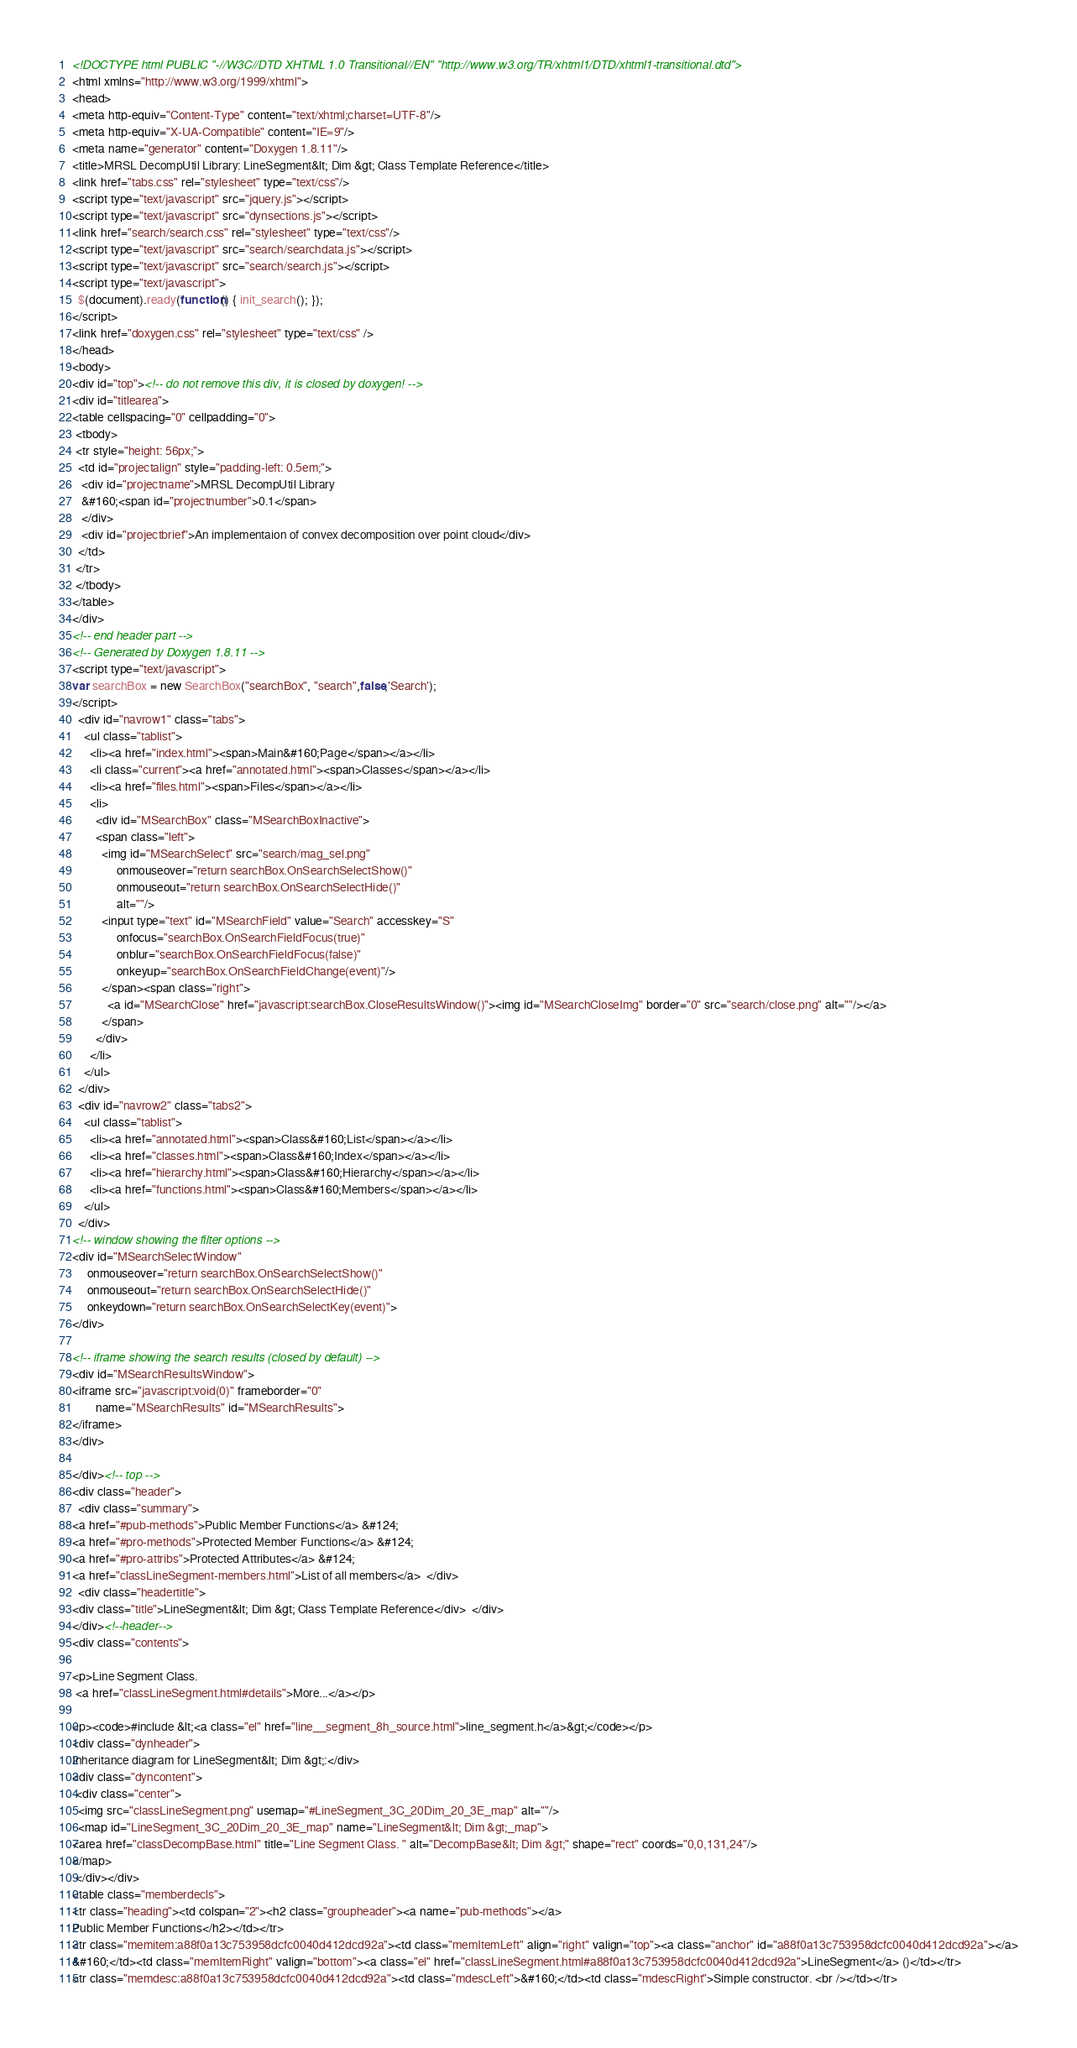<code> <loc_0><loc_0><loc_500><loc_500><_HTML_><!DOCTYPE html PUBLIC "-//W3C//DTD XHTML 1.0 Transitional//EN" "http://www.w3.org/TR/xhtml1/DTD/xhtml1-transitional.dtd">
<html xmlns="http://www.w3.org/1999/xhtml">
<head>
<meta http-equiv="Content-Type" content="text/xhtml;charset=UTF-8"/>
<meta http-equiv="X-UA-Compatible" content="IE=9"/>
<meta name="generator" content="Doxygen 1.8.11"/>
<title>MRSL DecompUtil Library: LineSegment&lt; Dim &gt; Class Template Reference</title>
<link href="tabs.css" rel="stylesheet" type="text/css"/>
<script type="text/javascript" src="jquery.js"></script>
<script type="text/javascript" src="dynsections.js"></script>
<link href="search/search.css" rel="stylesheet" type="text/css"/>
<script type="text/javascript" src="search/searchdata.js"></script>
<script type="text/javascript" src="search/search.js"></script>
<script type="text/javascript">
  $(document).ready(function() { init_search(); });
</script>
<link href="doxygen.css" rel="stylesheet" type="text/css" />
</head>
<body>
<div id="top"><!-- do not remove this div, it is closed by doxygen! -->
<div id="titlearea">
<table cellspacing="0" cellpadding="0">
 <tbody>
 <tr style="height: 56px;">
  <td id="projectalign" style="padding-left: 0.5em;">
   <div id="projectname">MRSL DecompUtil Library
   &#160;<span id="projectnumber">0.1</span>
   </div>
   <div id="projectbrief">An implementaion of convex decomposition over point cloud</div>
  </td>
 </tr>
 </tbody>
</table>
</div>
<!-- end header part -->
<!-- Generated by Doxygen 1.8.11 -->
<script type="text/javascript">
var searchBox = new SearchBox("searchBox", "search",false,'Search');
</script>
  <div id="navrow1" class="tabs">
    <ul class="tablist">
      <li><a href="index.html"><span>Main&#160;Page</span></a></li>
      <li class="current"><a href="annotated.html"><span>Classes</span></a></li>
      <li><a href="files.html"><span>Files</span></a></li>
      <li>
        <div id="MSearchBox" class="MSearchBoxInactive">
        <span class="left">
          <img id="MSearchSelect" src="search/mag_sel.png"
               onmouseover="return searchBox.OnSearchSelectShow()"
               onmouseout="return searchBox.OnSearchSelectHide()"
               alt=""/>
          <input type="text" id="MSearchField" value="Search" accesskey="S"
               onfocus="searchBox.OnSearchFieldFocus(true)" 
               onblur="searchBox.OnSearchFieldFocus(false)" 
               onkeyup="searchBox.OnSearchFieldChange(event)"/>
          </span><span class="right">
            <a id="MSearchClose" href="javascript:searchBox.CloseResultsWindow()"><img id="MSearchCloseImg" border="0" src="search/close.png" alt=""/></a>
          </span>
        </div>
      </li>
    </ul>
  </div>
  <div id="navrow2" class="tabs2">
    <ul class="tablist">
      <li><a href="annotated.html"><span>Class&#160;List</span></a></li>
      <li><a href="classes.html"><span>Class&#160;Index</span></a></li>
      <li><a href="hierarchy.html"><span>Class&#160;Hierarchy</span></a></li>
      <li><a href="functions.html"><span>Class&#160;Members</span></a></li>
    </ul>
  </div>
<!-- window showing the filter options -->
<div id="MSearchSelectWindow"
     onmouseover="return searchBox.OnSearchSelectShow()"
     onmouseout="return searchBox.OnSearchSelectHide()"
     onkeydown="return searchBox.OnSearchSelectKey(event)">
</div>

<!-- iframe showing the search results (closed by default) -->
<div id="MSearchResultsWindow">
<iframe src="javascript:void(0)" frameborder="0" 
        name="MSearchResults" id="MSearchResults">
</iframe>
</div>

</div><!-- top -->
<div class="header">
  <div class="summary">
<a href="#pub-methods">Public Member Functions</a> &#124;
<a href="#pro-methods">Protected Member Functions</a> &#124;
<a href="#pro-attribs">Protected Attributes</a> &#124;
<a href="classLineSegment-members.html">List of all members</a>  </div>
  <div class="headertitle">
<div class="title">LineSegment&lt; Dim &gt; Class Template Reference</div>  </div>
</div><!--header-->
<div class="contents">

<p>Line Segment Class.  
 <a href="classLineSegment.html#details">More...</a></p>

<p><code>#include &lt;<a class="el" href="line__segment_8h_source.html">line_segment.h</a>&gt;</code></p>
<div class="dynheader">
Inheritance diagram for LineSegment&lt; Dim &gt;:</div>
<div class="dyncontent">
 <div class="center">
  <img src="classLineSegment.png" usemap="#LineSegment_3C_20Dim_20_3E_map" alt=""/>
  <map id="LineSegment_3C_20Dim_20_3E_map" name="LineSegment&lt; Dim &gt;_map">
<area href="classDecompBase.html" title="Line Segment Class. " alt="DecompBase&lt; Dim &gt;" shape="rect" coords="0,0,131,24"/>
</map>
 </div></div>
<table class="memberdecls">
<tr class="heading"><td colspan="2"><h2 class="groupheader"><a name="pub-methods"></a>
Public Member Functions</h2></td></tr>
<tr class="memitem:a88f0a13c753958dcfc0040d412dcd92a"><td class="memItemLeft" align="right" valign="top"><a class="anchor" id="a88f0a13c753958dcfc0040d412dcd92a"></a>
&#160;</td><td class="memItemRight" valign="bottom"><a class="el" href="classLineSegment.html#a88f0a13c753958dcfc0040d412dcd92a">LineSegment</a> ()</td></tr>
<tr class="memdesc:a88f0a13c753958dcfc0040d412dcd92a"><td class="mdescLeft">&#160;</td><td class="mdescRight">Simple constructor. <br /></td></tr></code> 